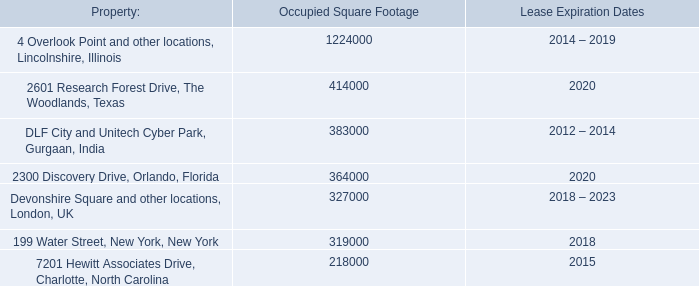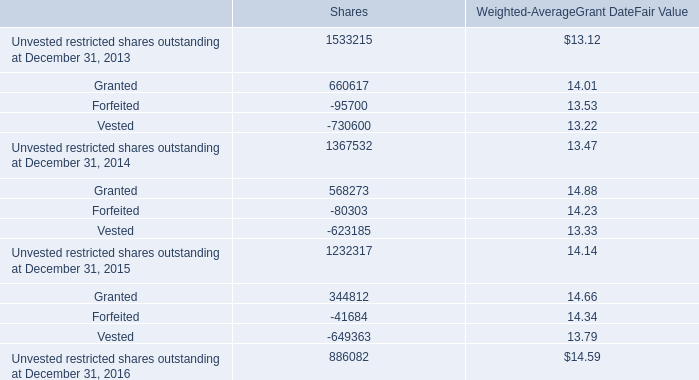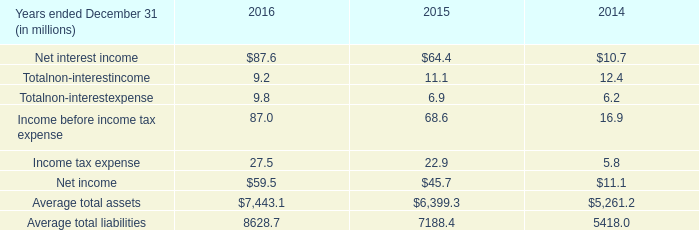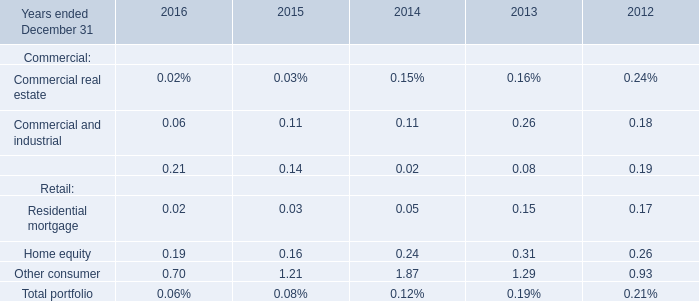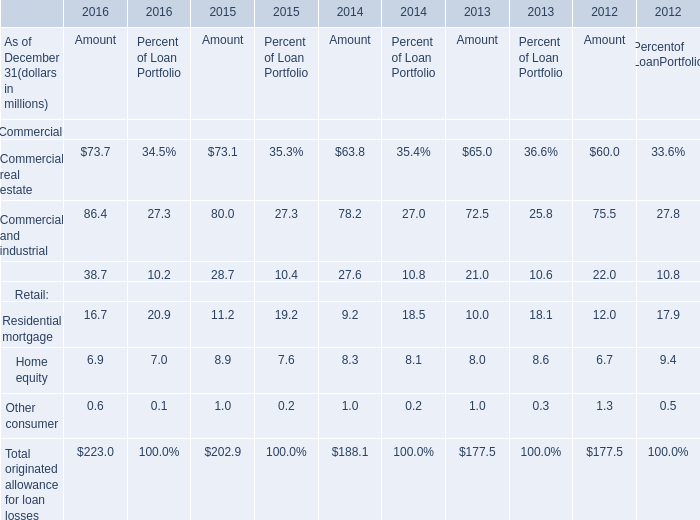When is Commercial and industrial for Amount the largest? 
Answer: 2016. 